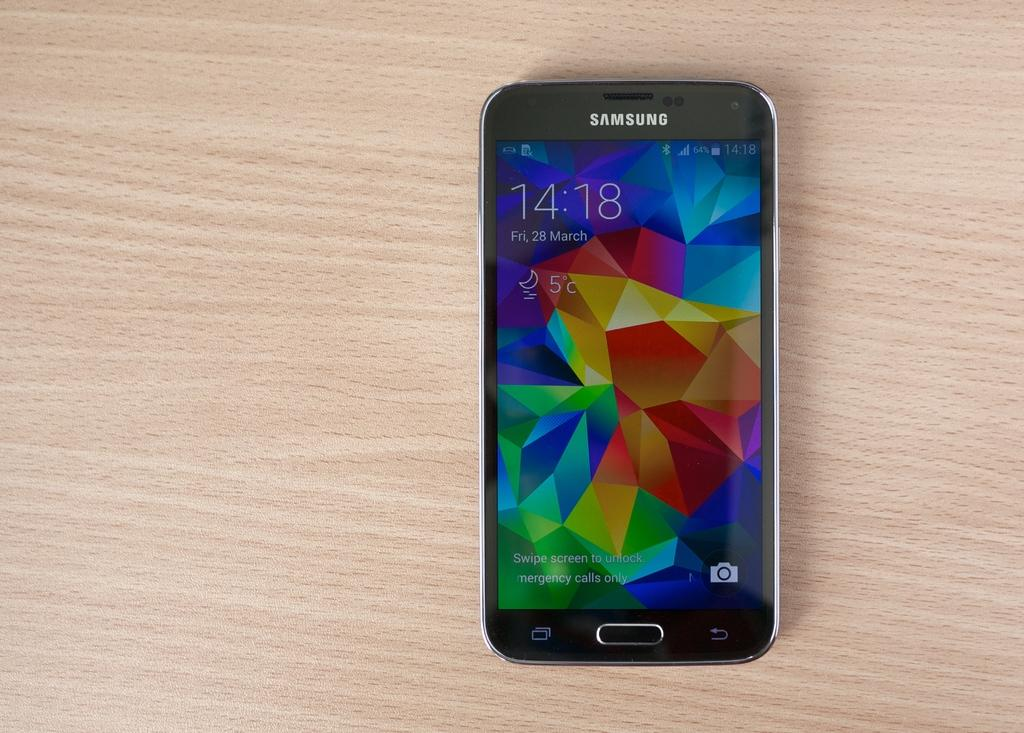<image>
Provide a brief description of the given image. A Samsung phone sits on a wooden counter at 14:18 on Friday March 28th. 